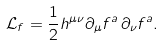Convert formula to latex. <formula><loc_0><loc_0><loc_500><loc_500>\mathcal { L } _ { f } = \frac { 1 } { 2 } h ^ { \mu \nu } \partial _ { \mu } f ^ { a } \, \partial _ { \nu } f ^ { a } .</formula> 